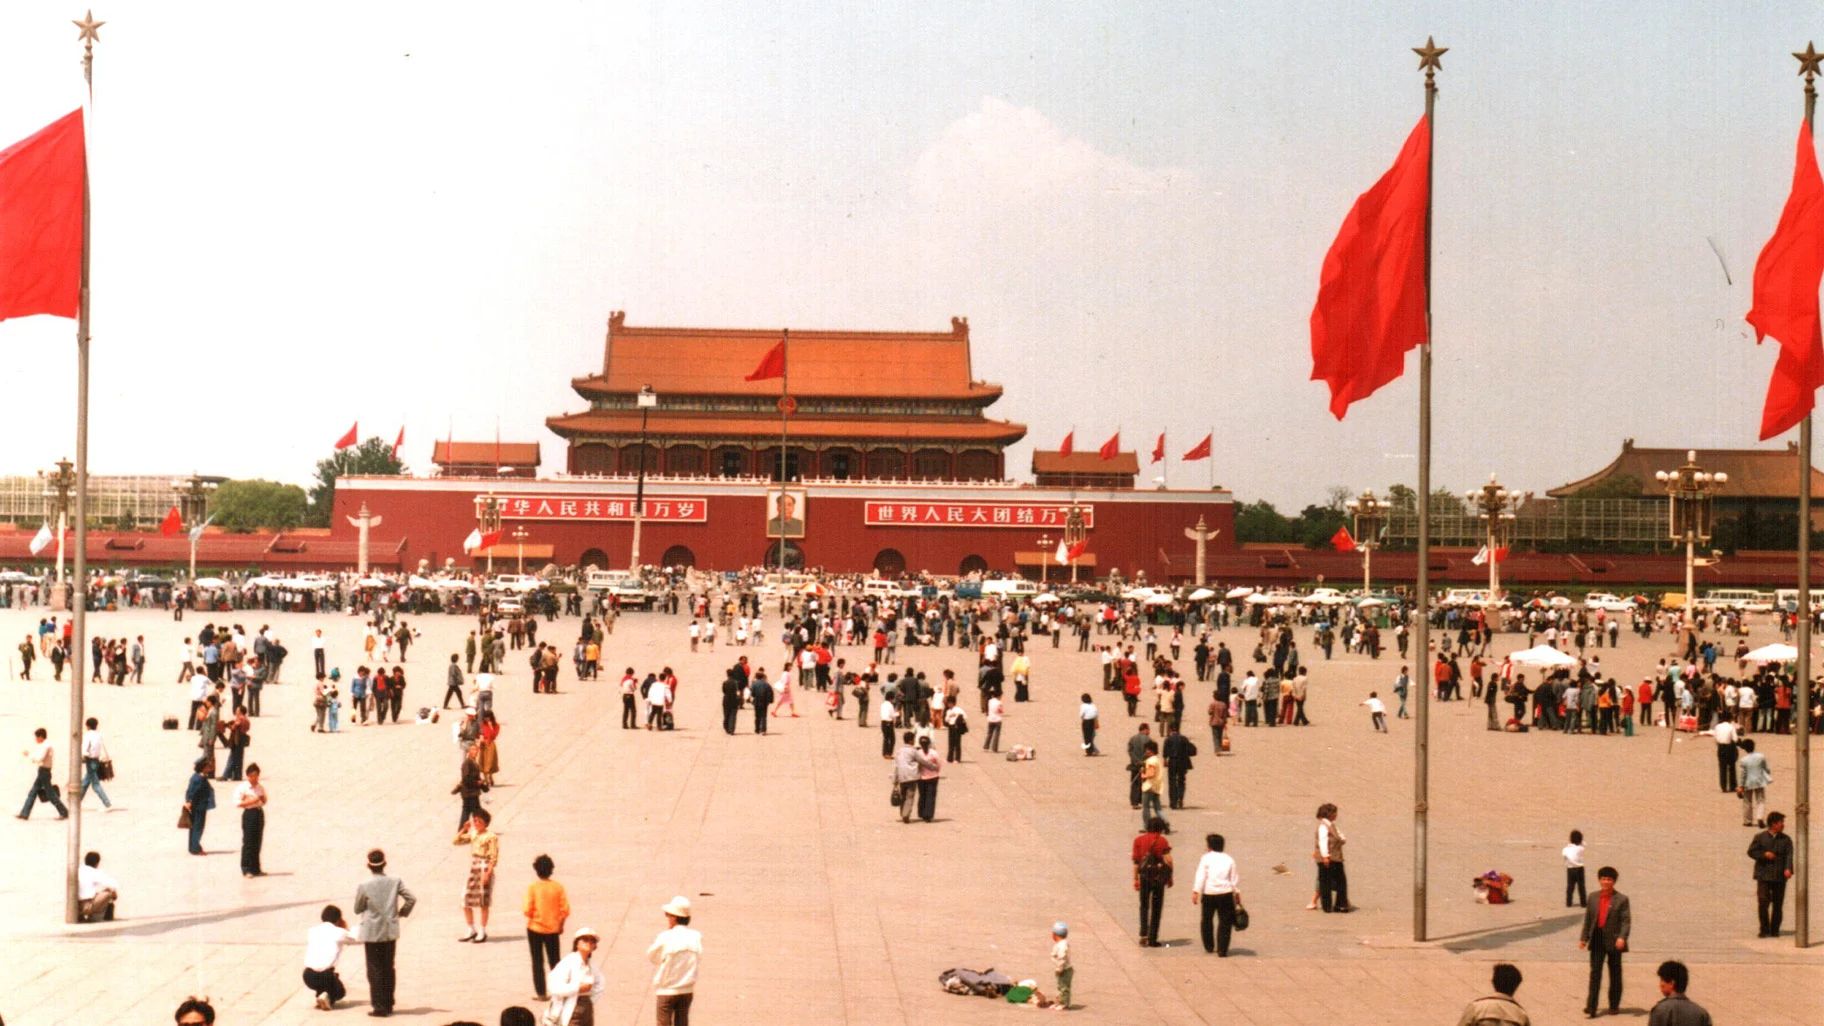What are people likely experiencing and feeling during a national celebration here? During a national celebration at Tiananmen Square, people likely feel a profound sense of pride and unity. The atmosphere is electric with excitement and festivity as the crowd gathers to partake in the day's events. Colorful parades featuring elaborately decorated floats, traditional dances, and musical performances captivate the audience. Spectators are filled with awe as they witness the grand spectacle of fireworks illuminating the night sky. The sense of shared history and cultural heritage strengthens communal bonds, creating a joyous and emotionally resonant experience. It's a day marked by celebration, reflection, and a deep connection to the nation's enduring legacy. 